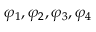Convert formula to latex. <formula><loc_0><loc_0><loc_500><loc_500>\varphi _ { 1 } , \varphi _ { 2 } , \varphi _ { 3 } , \varphi _ { 4 }</formula> 